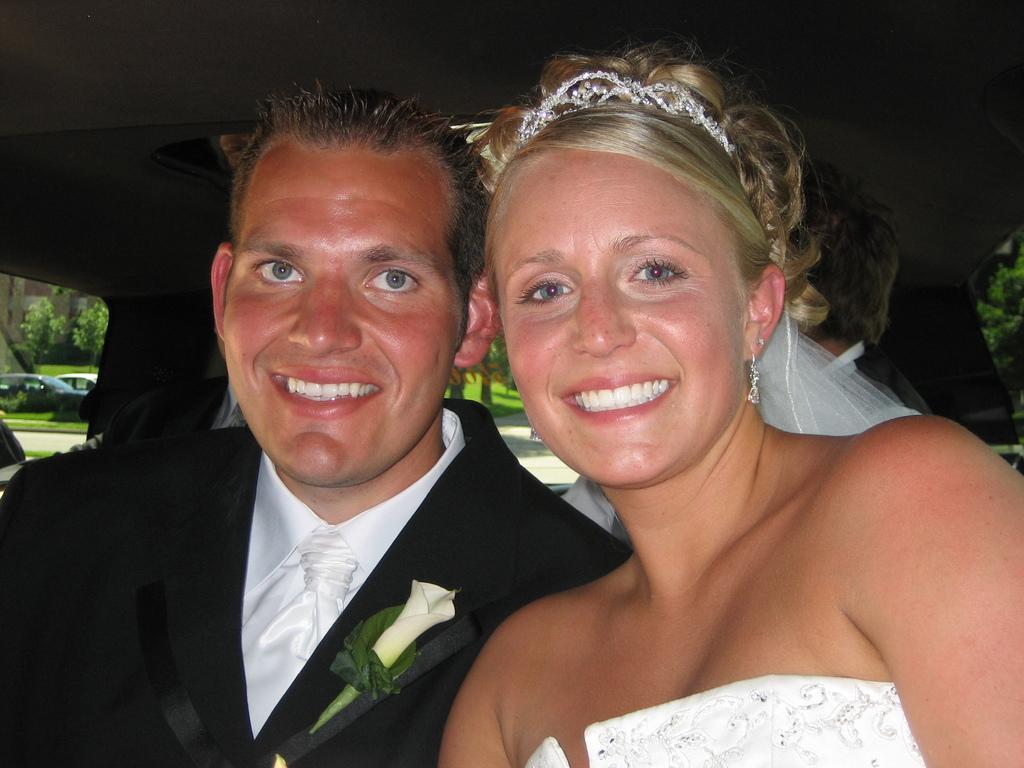In one or two sentences, can you explain what this image depicts? In this picture there is a man and a woman in the center of the image. 